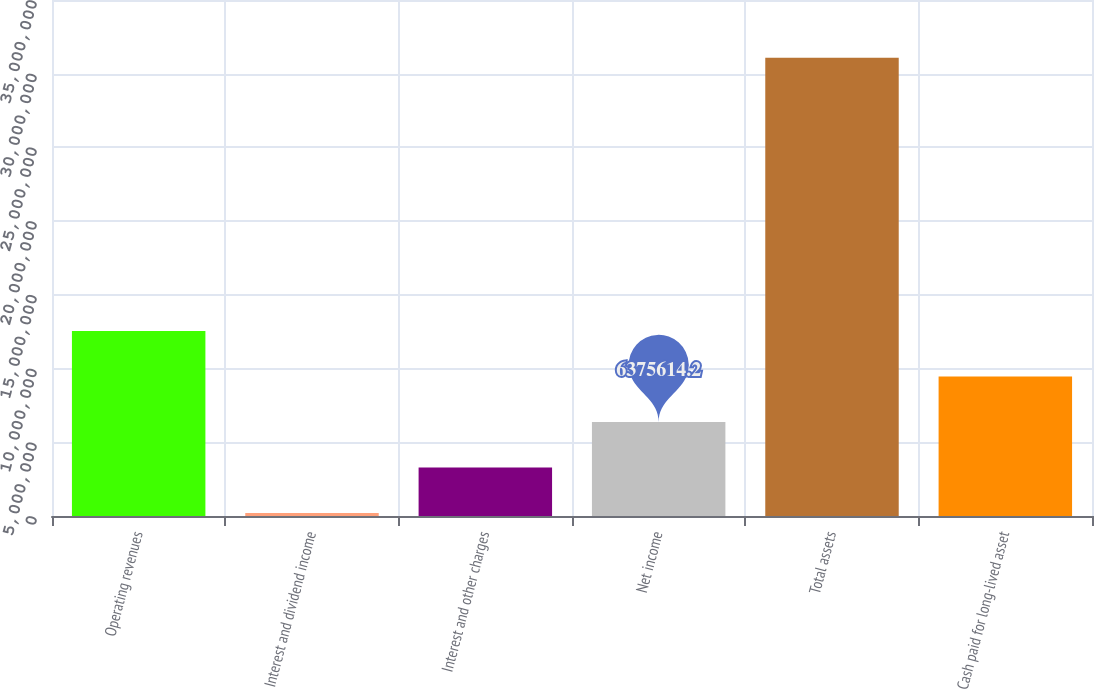Convert chart. <chart><loc_0><loc_0><loc_500><loc_500><bar_chart><fcel>Operating revenues<fcel>Interest and dividend income<fcel>Interest and other charges<fcel>Net income<fcel>Total assets<fcel>Cash paid for long-lived asset<nl><fcel>1.25524e+07<fcel>198835<fcel>3.28722e+06<fcel>6.37561e+06<fcel>3.10827e+07<fcel>9.464e+06<nl></chart> 